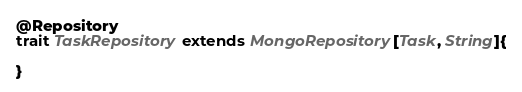Convert code to text. <code><loc_0><loc_0><loc_500><loc_500><_Scala_>
@Repository
trait TaskRepository extends MongoRepository[Task, String]{

}
</code> 